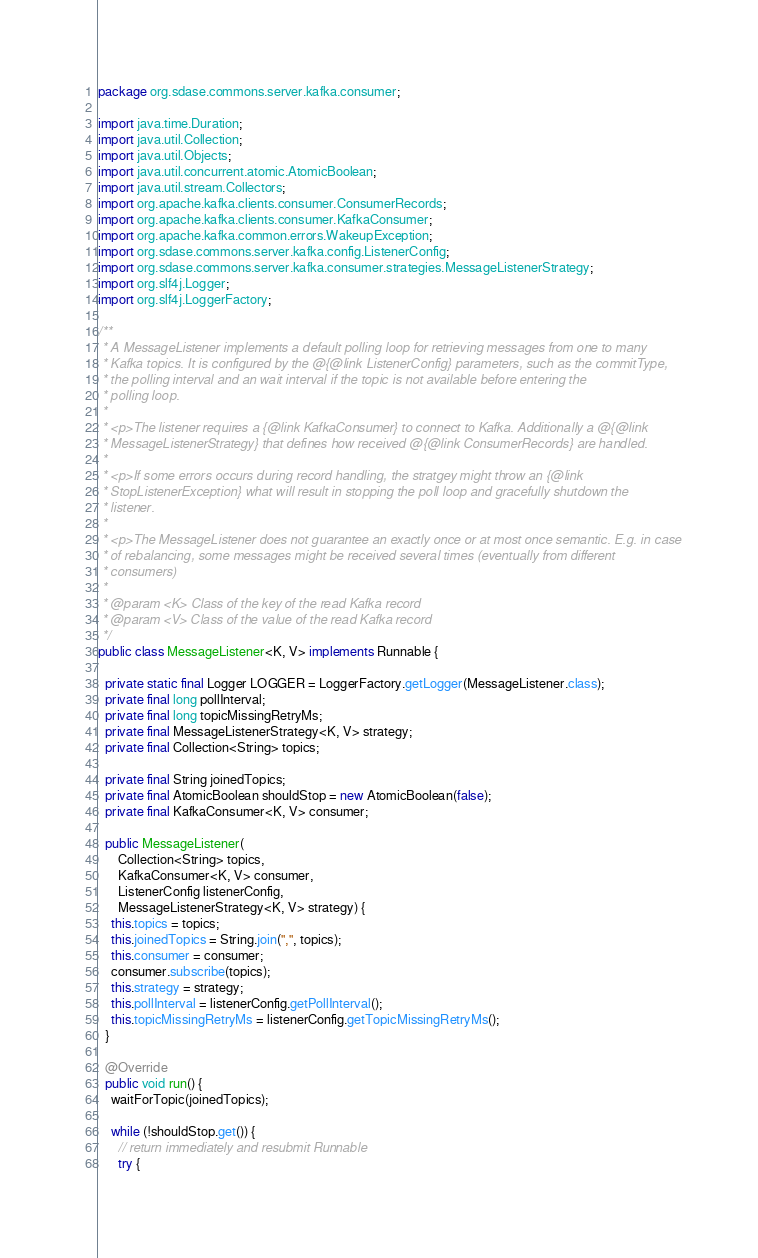Convert code to text. <code><loc_0><loc_0><loc_500><loc_500><_Java_>package org.sdase.commons.server.kafka.consumer;

import java.time.Duration;
import java.util.Collection;
import java.util.Objects;
import java.util.concurrent.atomic.AtomicBoolean;
import java.util.stream.Collectors;
import org.apache.kafka.clients.consumer.ConsumerRecords;
import org.apache.kafka.clients.consumer.KafkaConsumer;
import org.apache.kafka.common.errors.WakeupException;
import org.sdase.commons.server.kafka.config.ListenerConfig;
import org.sdase.commons.server.kafka.consumer.strategies.MessageListenerStrategy;
import org.slf4j.Logger;
import org.slf4j.LoggerFactory;

/**
 * A MessageListener implements a default polling loop for retrieving messages from one to many
 * Kafka topics. It is configured by the @{@link ListenerConfig} parameters, such as the commitType,
 * the polling interval and an wait interval if the topic is not available before entering the
 * polling loop.
 *
 * <p>The listener requires a {@link KafkaConsumer} to connect to Kafka. Additionally a @{@link
 * MessageListenerStrategy} that defines how received @{@link ConsumerRecords} are handled.
 *
 * <p>If some errors occurs during record handling, the stratgey might throw an {@link
 * StopListenerException} what will result in stopping the poll loop and gracefully shutdown the
 * listener.
 *
 * <p>The MessageListener does not guarantee an exactly once or at most once semantic. E.g. in case
 * of rebalancing, some messages might be received several times (eventually from different
 * consumers)
 *
 * @param <K> Class of the key of the read Kafka record
 * @param <V> Class of the value of the read Kafka record
 */
public class MessageListener<K, V> implements Runnable {

  private static final Logger LOGGER = LoggerFactory.getLogger(MessageListener.class);
  private final long pollInterval;
  private final long topicMissingRetryMs;
  private final MessageListenerStrategy<K, V> strategy;
  private final Collection<String> topics;

  private final String joinedTopics;
  private final AtomicBoolean shouldStop = new AtomicBoolean(false);
  private final KafkaConsumer<K, V> consumer;

  public MessageListener(
      Collection<String> topics,
      KafkaConsumer<K, V> consumer,
      ListenerConfig listenerConfig,
      MessageListenerStrategy<K, V> strategy) {
    this.topics = topics;
    this.joinedTopics = String.join(",", topics);
    this.consumer = consumer;
    consumer.subscribe(topics);
    this.strategy = strategy;
    this.pollInterval = listenerConfig.getPollInterval();
    this.topicMissingRetryMs = listenerConfig.getTopicMissingRetryMs();
  }

  @Override
  public void run() {
    waitForTopic(joinedTopics);

    while (!shouldStop.get()) {
      // return immediately and resubmit Runnable
      try {</code> 